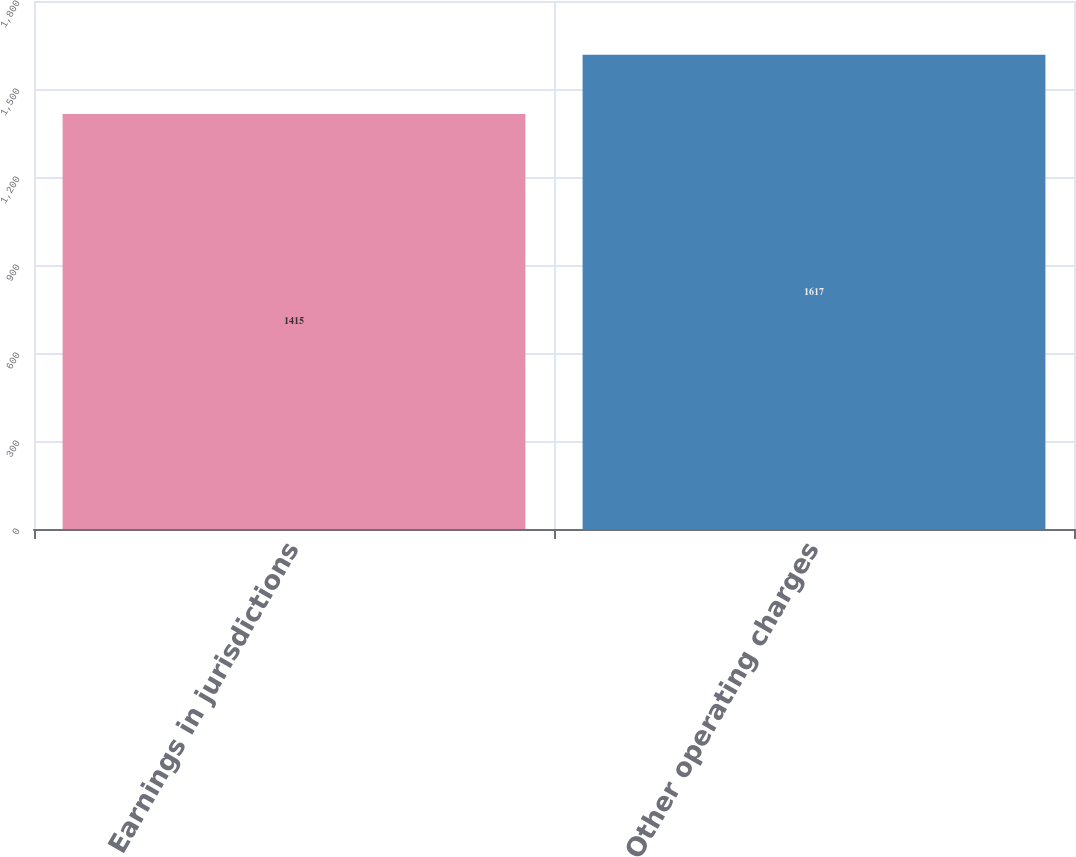<chart> <loc_0><loc_0><loc_500><loc_500><bar_chart><fcel>Earnings in jurisdictions<fcel>Other operating charges<nl><fcel>1415<fcel>1617<nl></chart> 